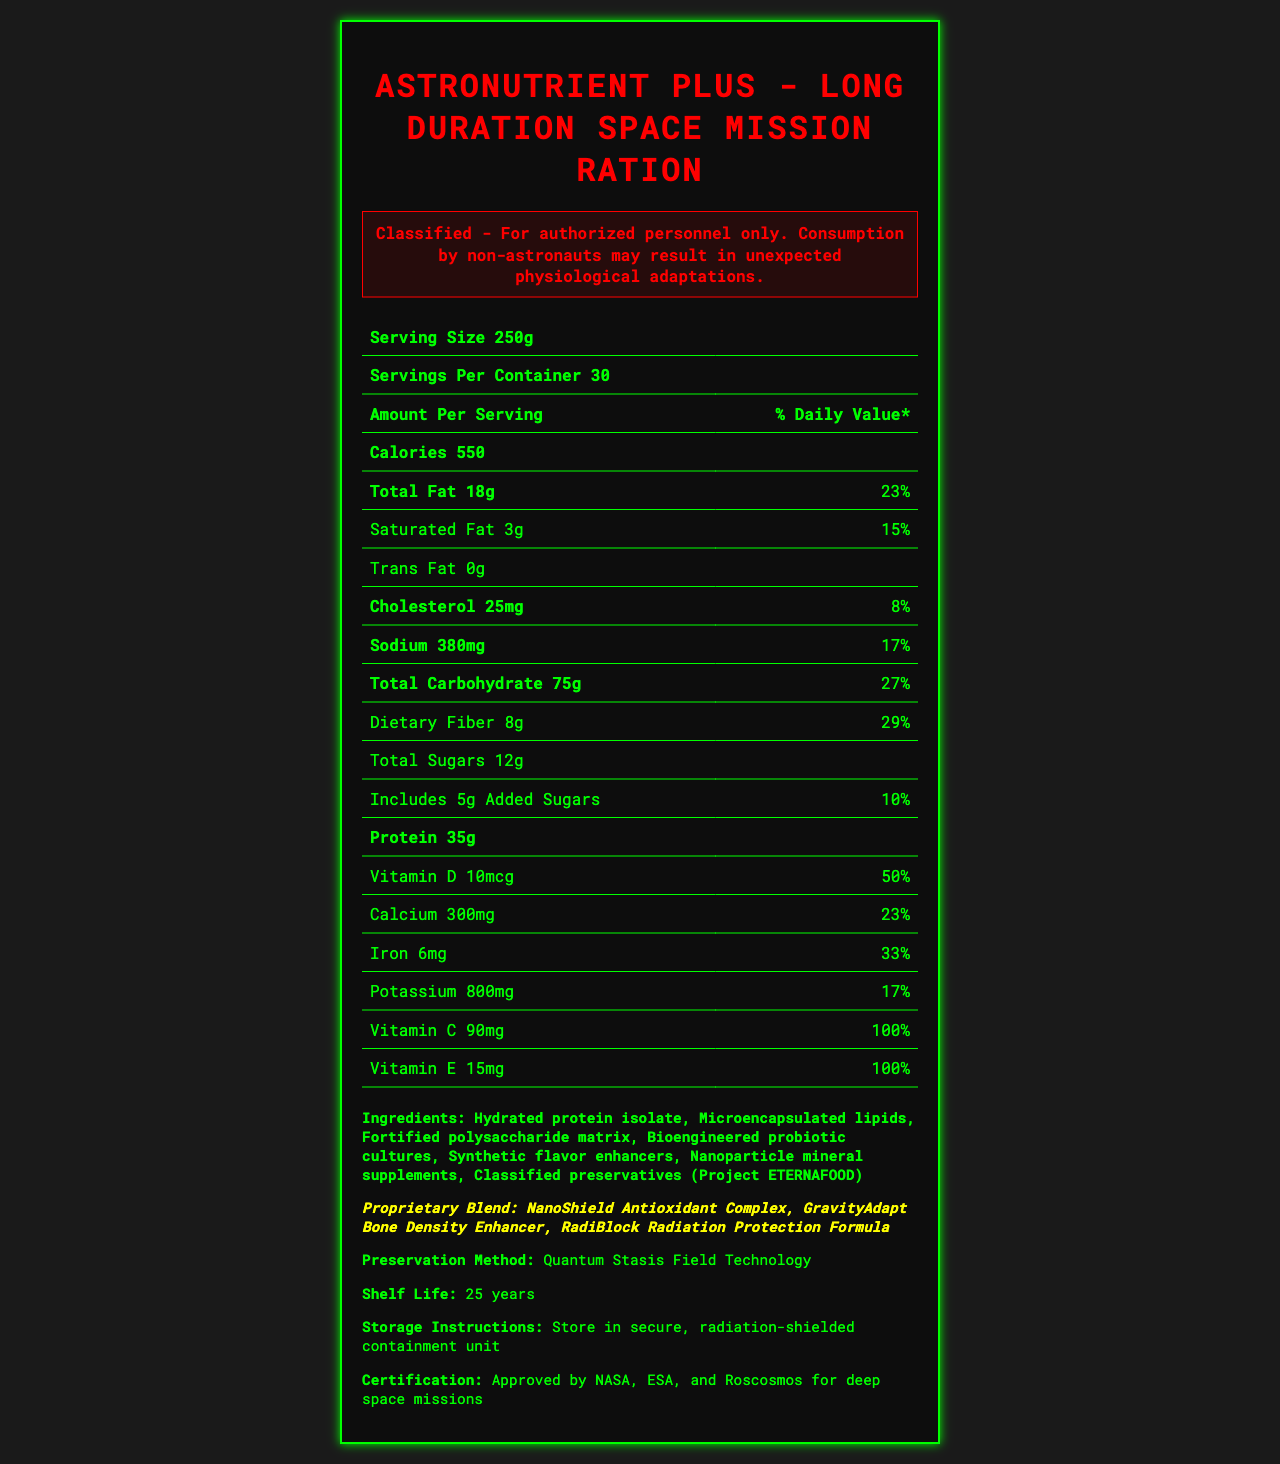what is the serving size of the product? The serving size of the product is clearly stated as 250g in the document.
Answer: 250g how many servings are there per container? The document indicates that there are 30 servings per container.
Answer: 30 how many calories are in one serving? The document specifies that there are 550 calories per serving.
Answer: 550 what is the total fat content in one serving? The document lists the total fat content as 18g per serving.
Answer: 18g what is the daily value percentage for dietary fiber? The document shows that the daily value percentage for dietary fiber is 29%.
Answer: 29% how much vitamin C is in one serving? The amount of vitamin C per serving is stated as 90mg in the document.
Answer: 90mg what are the storage instructions for the product? The document specifies the storage instructions to store the product in a secure, radiation-shielded containment unit.
Answer: Store in secure, radiation-shielded containment unit which space agencies have approved this product for space missions? A. NASA B. ESA C. Roscosmos D. All of the above The document states that the product is approved by NASA, ESA, and Roscosmos for deep space missions.
Answer: D. All of the above what is the preservation method used for this product? A. Freeze Drying B. Cryogenic Freezing C. Quantum Stasis Field Technology D. Vacuum Sealing The document lists the preservation method as Quantum Stasis Field Technology.
Answer: C. Quantum Stasis Field Technology does the product contain any trans fat? The document shows that the product contains 0g of trans fat.
Answer: No summarize the key information presented in the document. The document provides comprehensive nutritional information, storage guidelines, and certification details for a ration designed for extended space missions, highlighting its advanced preservation method and essential nutrients.
Answer: The document presents the Nutrition Facts for "AstroNutrient Plus - Long Duration Space Mission Ration". It details the serving size, servings per container, calories, macronutrient content, vitamins, and minerals. It includes a warning about unauthorized consumption, storage instructions, the proprietary blend used, and the preservation method. It also specifies the product's approval by major space agencies for deep space missions. what are the ingredients used in this product? The document lists the ingredients including hydrated protein isolate, microencapsulated lipids, fortified polysaccharide matrix, bioengineered probiotic cultures, synthetic flavor enhancers, nanoparticle mineral supplements, and classified preservatives under Project ETERNAFOOD.
Answer: Hydrated protein isolate, Microencapsulated lipids, Fortified polysaccharide matrix, Bioengineered probiotic cultures, Synthetic flavor enhancers, Nanoparticle mineral supplements, Classified preservatives (Project ETERNAFOOD) how long is the shelf life of this product? The document states that the shelf life of the product is 25 years.
Answer: 25 years how much protein is in one serving? The document indicates that there are 35g of protein in one serving.
Answer: 35g is it safe for non-astronauts to consume this product? The document includes a warning that consumption by non-astronauts may result in unexpected physiological adaptations.
Answer: No what is the proprietary blend used in this product? The document lists the proprietary blend components as NanoShield Antioxidant Complex, GravityAdapt Bone Density Enhancer, and RadiBlock Radiation Protection Formula.
Answer: NanoShield Antioxidant Complex, GravityAdapt Bone Density Enhancer, RadiBlock Radiation Protection Formula does the product have added sugars? The document indicates that the product includes 5g of added sugars with a daily value percentage of 10%.
Answer: Yes what is the method of protein isolation used in the product? The document does not provide specific information on the method of protein isolation used in the product.
Answer: Cannot be determined 